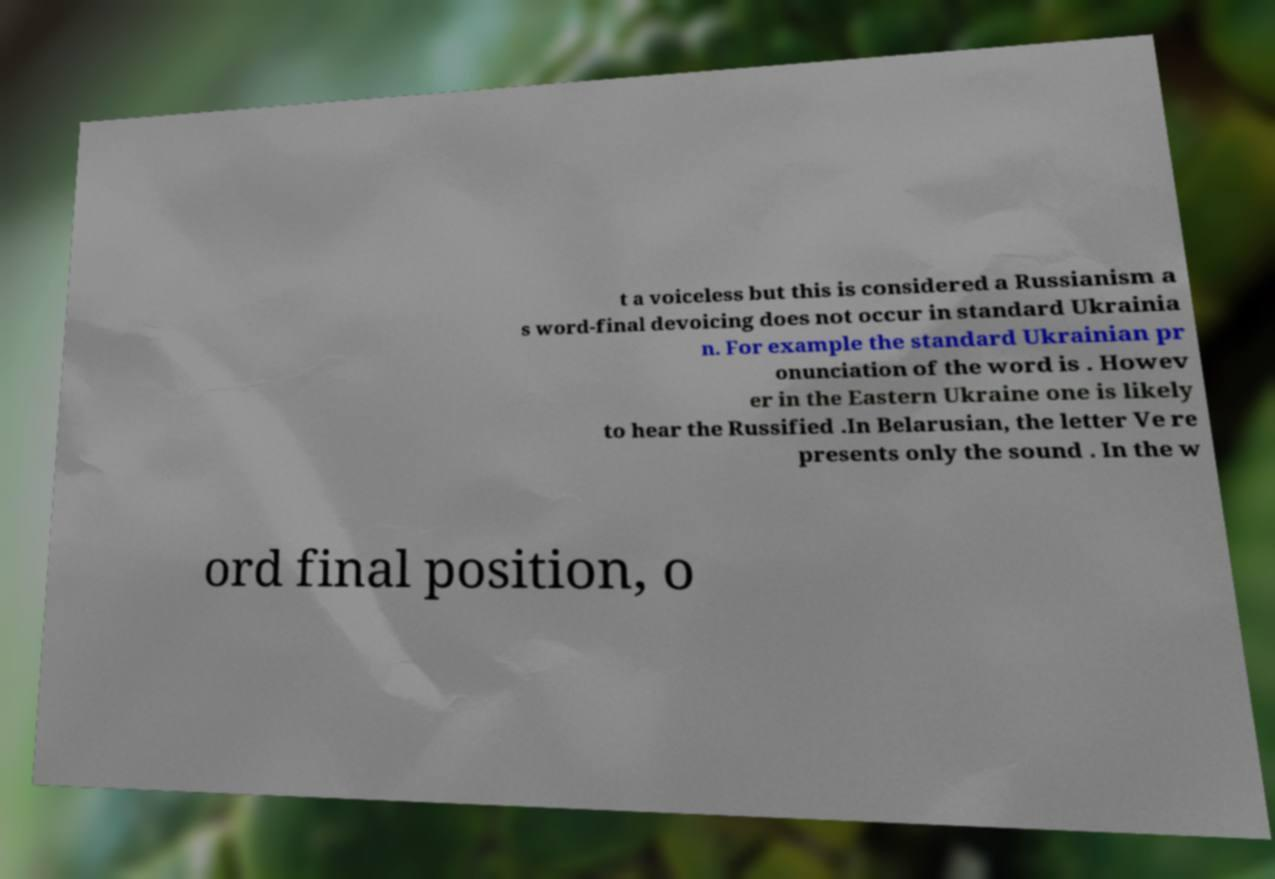For documentation purposes, I need the text within this image transcribed. Could you provide that? t a voiceless but this is considered a Russianism a s word-final devoicing does not occur in standard Ukrainia n. For example the standard Ukrainian pr onunciation of the word is . Howev er in the Eastern Ukraine one is likely to hear the Russified .In Belarusian, the letter Ve re presents only the sound . In the w ord final position, o 